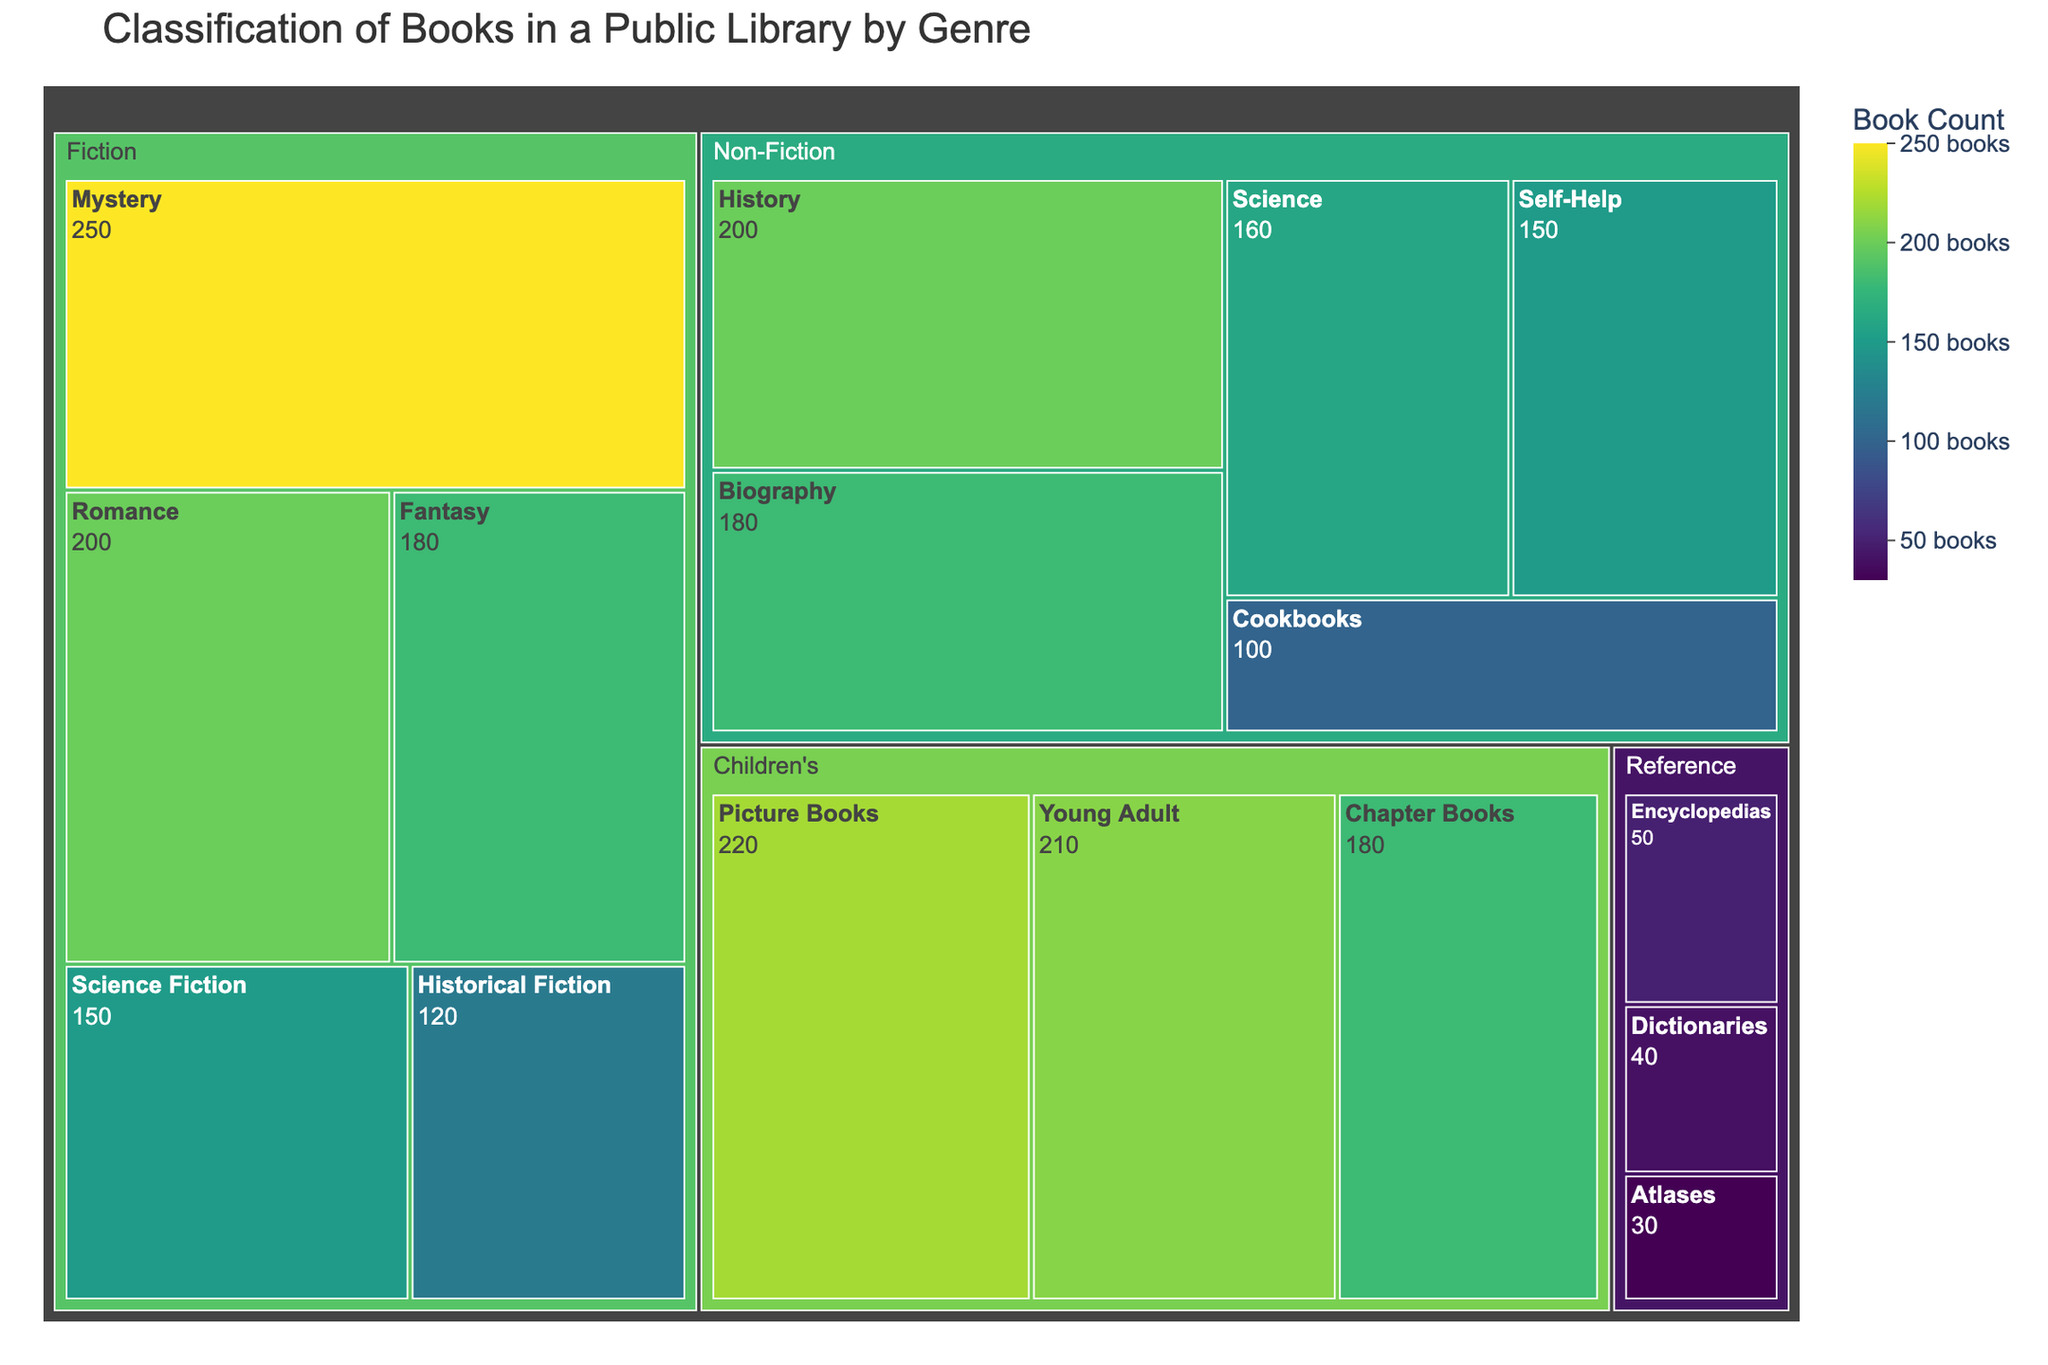What's the title of the treemap? The title of the treemap is displayed at the top of the figure. It is usually centered and uses a larger, bold font for emphasis.
Answer: Classification of Books in a Public Library by Genre Which category has the most books under the Children's genre? To determine which category has the most books under the Children's genre, look at the size of the sections within the Children's area of the treemap. The largest section corresponds to the category with the highest count.
Answer: Picture Books How many books are there in the Romance category within Fiction? Find the Romance category under the Fiction genre in the treemap. The number of books is indicated within that specific section.
Answer: 200 Which genre has the fewest total books? Assess the overall size of each genre section within the treemap and compare them. The genre with the smallest overall area has the fewest total books.
Answer: Reference What's the combined book count for the Science Fiction and Fantasy categories under Fiction? First, find the Science Fiction and Fantasy sections under the Fiction genre. Add their respective book counts together: 150 (Science Fiction) + 180 (Fantasy) = 330.
Answer: 330 Which genre has more books: Non-Fiction or Children's? Compare the overall size of the Non-Fiction and Children's sections in the treemap. The genre with the larger overall area has more books.
Answer: Non-Fiction How many categories are there in the Reference genre? Count the individual sections within the Reference area of the treemap to find how many distinct categories are present.
Answer: 3 Does Historical Fiction have more books than Science within Non-Fiction? Compare the sizes of the Historical Fiction section under Fiction and the Science section under Non-Fiction. Historical Fiction has 120 books, while Science has 160 books.
Answer: No What is the average number of books per category in the Non-Fiction genre? Calculate the average by summing the book counts for all Non-Fiction categories and dividing by the number of categories. (180 + 150 + 200 + 160 + 100) / 5 = 158.
Answer: 158 Between Biographies and Young Adult, which category has a higher book count, and by how much? Compare the book counts: Biographies have 180 books, and Young Adult has 210 books. Subtract to determine the difference: 210 - 180 = 30.
Answer: Young Adult by 30 